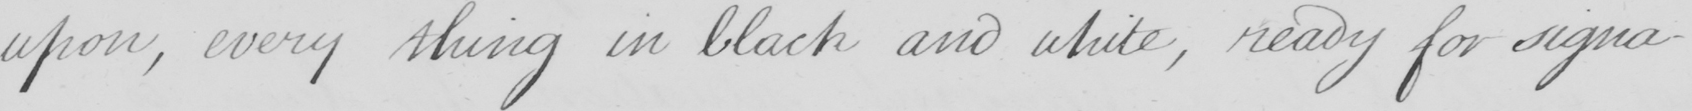What text is written in this handwritten line? upon , every thing in black and white , ready for signa- 